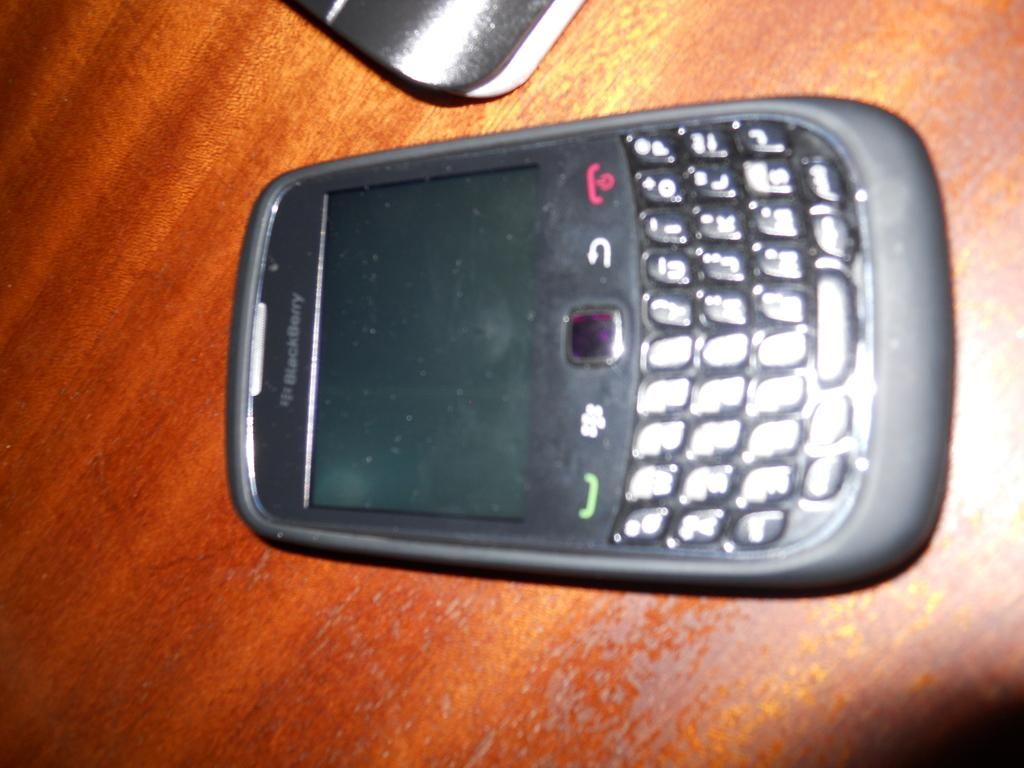<image>
Offer a succinct explanation of the picture presented. A blackberry phone is off and lying on a wooden surface. 